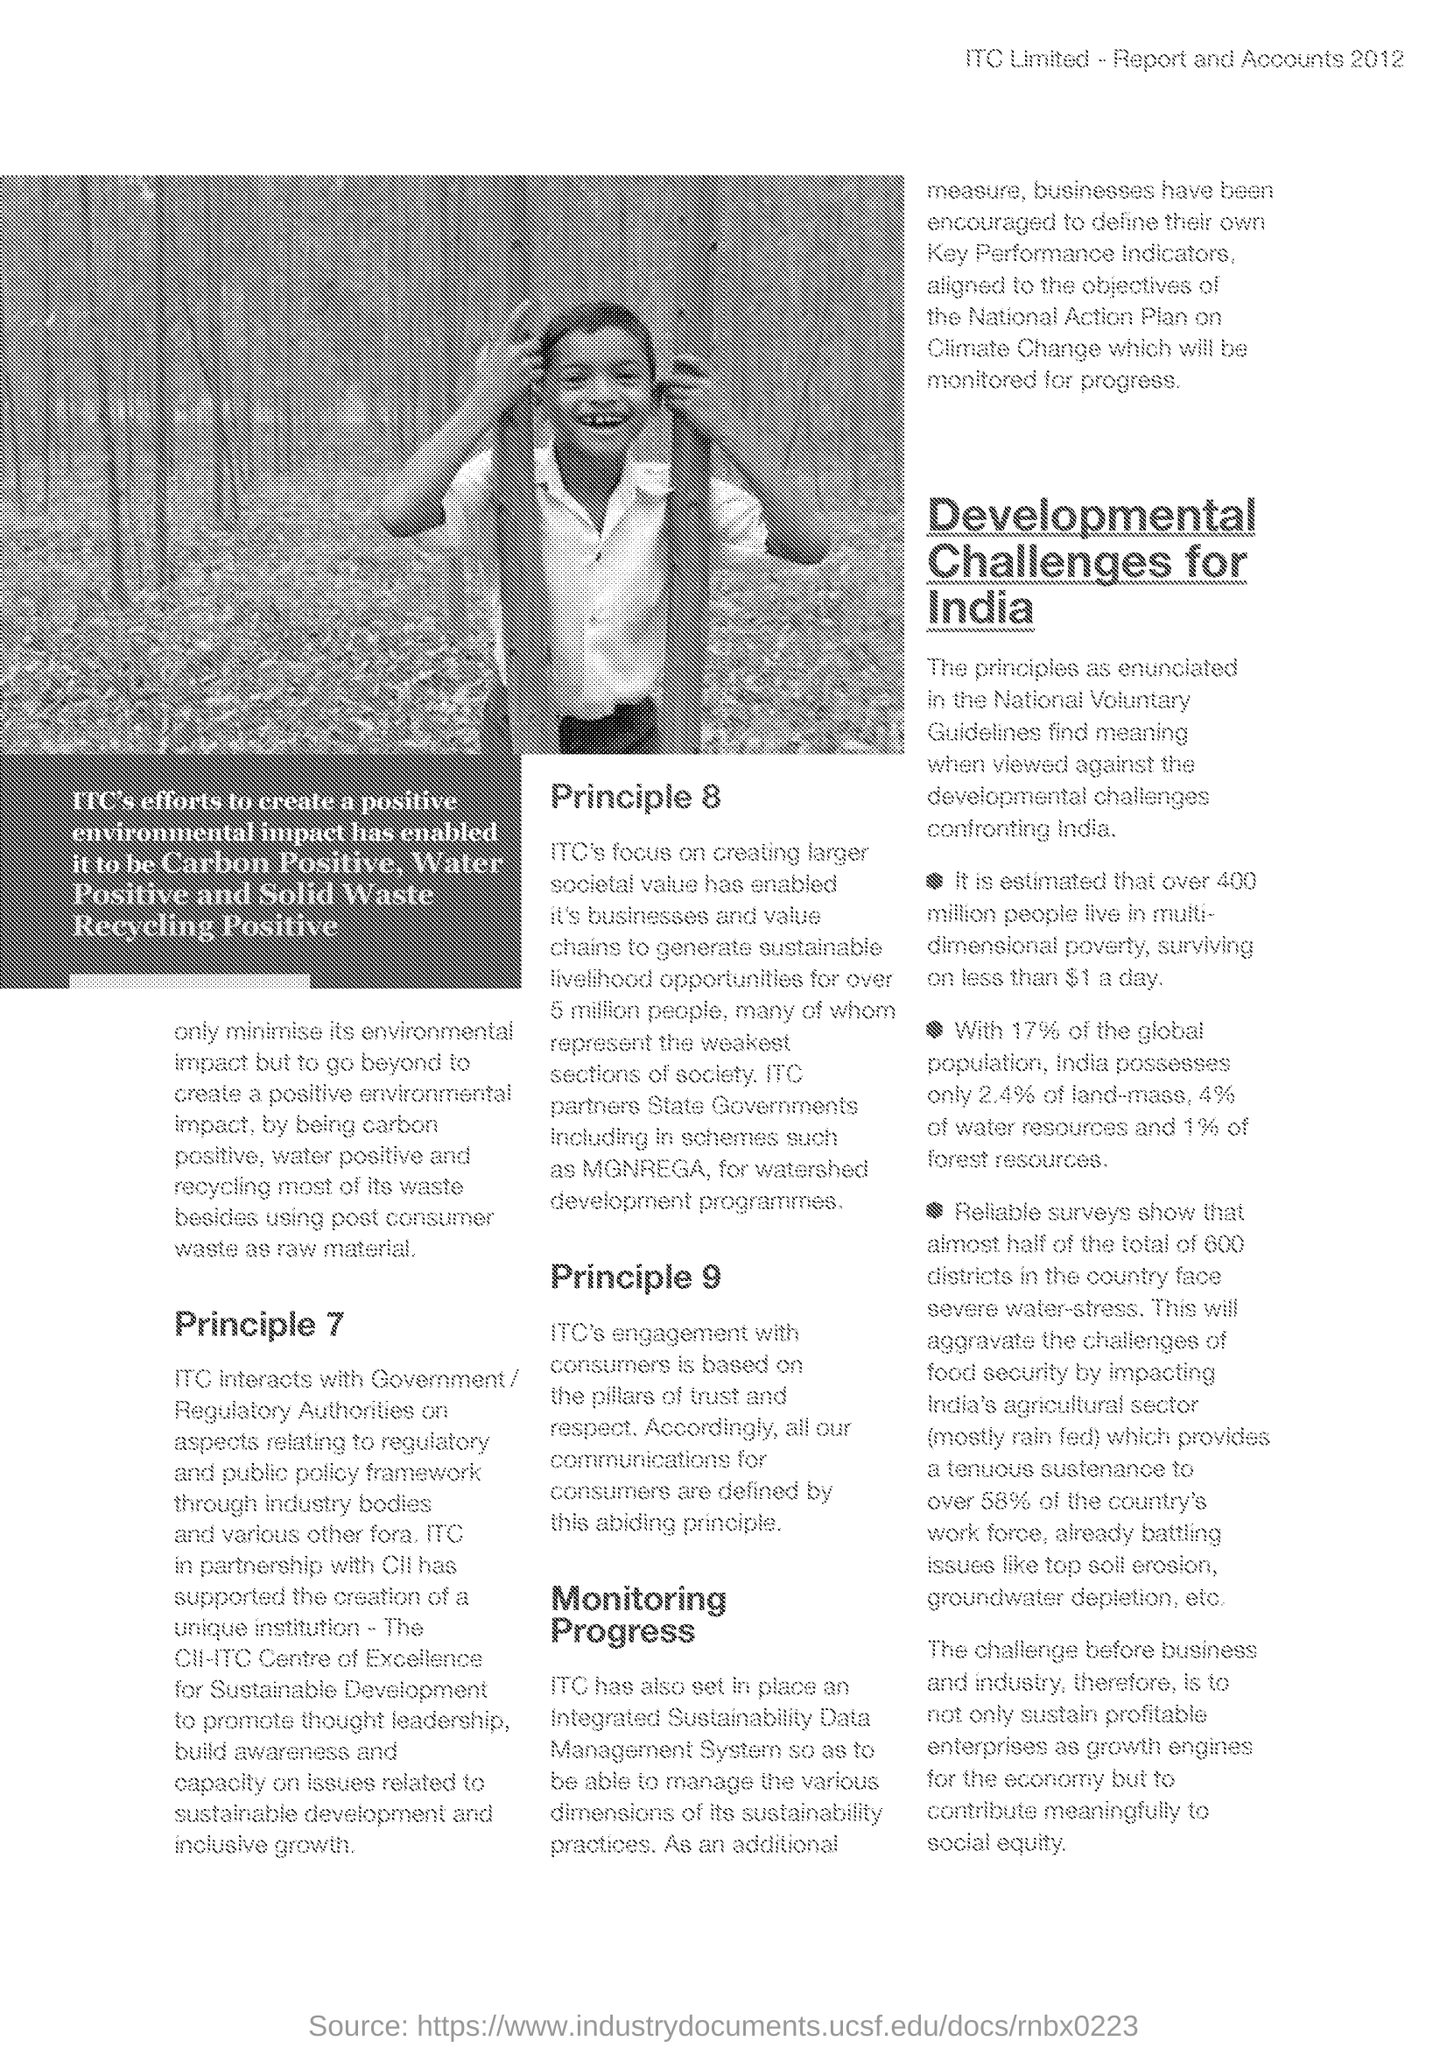Give some essential details in this illustration. The document lists development challenges for the country of India. India possesses approximately 4% of the world's water resources. ITC, in partnership with [company name], has supported the creation of a one-of-a-kind institution. India possesses approximately 17% of the global population. India possesses approximately 24.2% of the total global forest resources. 